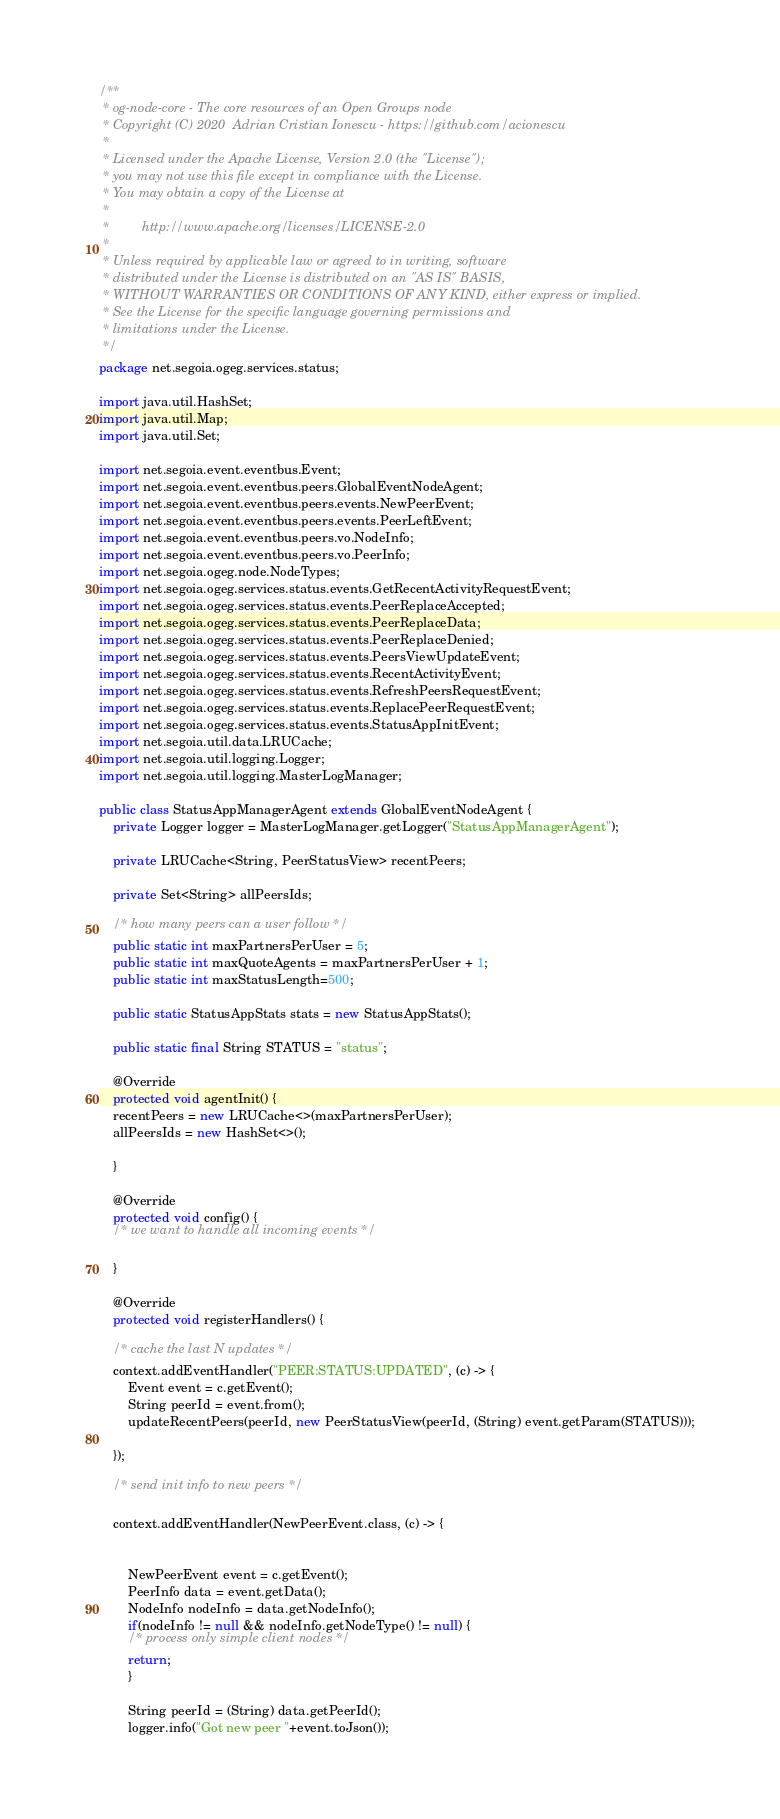Convert code to text. <code><loc_0><loc_0><loc_500><loc_500><_Java_>/**
 * og-node-core - The core resources of an Open Groups node
 * Copyright (C) 2020  Adrian Cristian Ionescu - https://github.com/acionescu
 *
 * Licensed under the Apache License, Version 2.0 (the "License");
 * you may not use this file except in compliance with the License.
 * You may obtain a copy of the License at
 *
 *         http://www.apache.org/licenses/LICENSE-2.0
 *
 * Unless required by applicable law or agreed to in writing, software
 * distributed under the License is distributed on an "AS IS" BASIS,
 * WITHOUT WARRANTIES OR CONDITIONS OF ANY KIND, either express or implied.
 * See the License for the specific language governing permissions and
 * limitations under the License.
 */
package net.segoia.ogeg.services.status;

import java.util.HashSet;
import java.util.Map;
import java.util.Set;

import net.segoia.event.eventbus.Event;
import net.segoia.event.eventbus.peers.GlobalEventNodeAgent;
import net.segoia.event.eventbus.peers.events.NewPeerEvent;
import net.segoia.event.eventbus.peers.events.PeerLeftEvent;
import net.segoia.event.eventbus.peers.vo.NodeInfo;
import net.segoia.event.eventbus.peers.vo.PeerInfo;
import net.segoia.ogeg.node.NodeTypes;
import net.segoia.ogeg.services.status.events.GetRecentActivityRequestEvent;
import net.segoia.ogeg.services.status.events.PeerReplaceAccepted;
import net.segoia.ogeg.services.status.events.PeerReplaceData;
import net.segoia.ogeg.services.status.events.PeerReplaceDenied;
import net.segoia.ogeg.services.status.events.PeersViewUpdateEvent;
import net.segoia.ogeg.services.status.events.RecentActivityEvent;
import net.segoia.ogeg.services.status.events.RefreshPeersRequestEvent;
import net.segoia.ogeg.services.status.events.ReplacePeerRequestEvent;
import net.segoia.ogeg.services.status.events.StatusAppInitEvent;
import net.segoia.util.data.LRUCache;
import net.segoia.util.logging.Logger;
import net.segoia.util.logging.MasterLogManager;

public class StatusAppManagerAgent extends GlobalEventNodeAgent {
    private Logger logger = MasterLogManager.getLogger("StatusAppManagerAgent");

    private LRUCache<String, PeerStatusView> recentPeers;

    private Set<String> allPeersIds;
    
    /* how many peers can a user follow */
    public static int maxPartnersPerUser = 5;
    public static int maxQuoteAgents = maxPartnersPerUser + 1;
    public static int maxStatusLength=500;

    public static StatusAppStats stats = new StatusAppStats();

    public static final String STATUS = "status";

    @Override
    protected void agentInit() {
	recentPeers = new LRUCache<>(maxPartnersPerUser);
	allPeersIds = new HashSet<>();

    }

    @Override
    protected void config() {
	/* we want to handle all incoming events */

    }

    @Override
    protected void registerHandlers() {

	/* cache the last N updates */
	context.addEventHandler("PEER:STATUS:UPDATED", (c) -> {
	    Event event = c.getEvent();
	    String peerId = event.from();
	    updateRecentPeers(peerId, new PeerStatusView(peerId, (String) event.getParam(STATUS)));

	});

	/* send init info to new peers */

	context.addEventHandler(NewPeerEvent.class, (c) -> {
	    
	    
	    NewPeerEvent event = c.getEvent();
	    PeerInfo data = event.getData();
	    NodeInfo nodeInfo = data.getNodeInfo();
	    if(nodeInfo != null && nodeInfo.getNodeType() != null) {
		/* process only simple client nodes */
		return;
	    }
	    
	    String peerId = (String) data.getPeerId();
	    logger.info("Got new peer "+event.toJson());</code> 